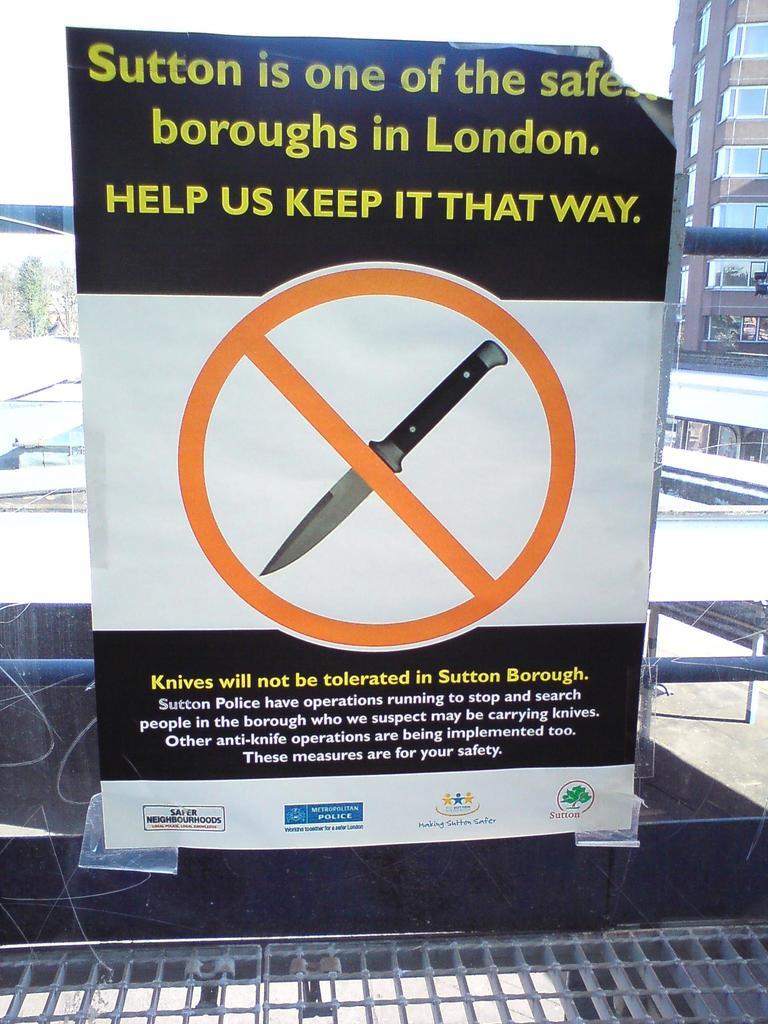Which borough is the safest in london?
Your answer should be very brief. Sutton. Is a knife mentioned here?
Provide a succinct answer. Yes. 